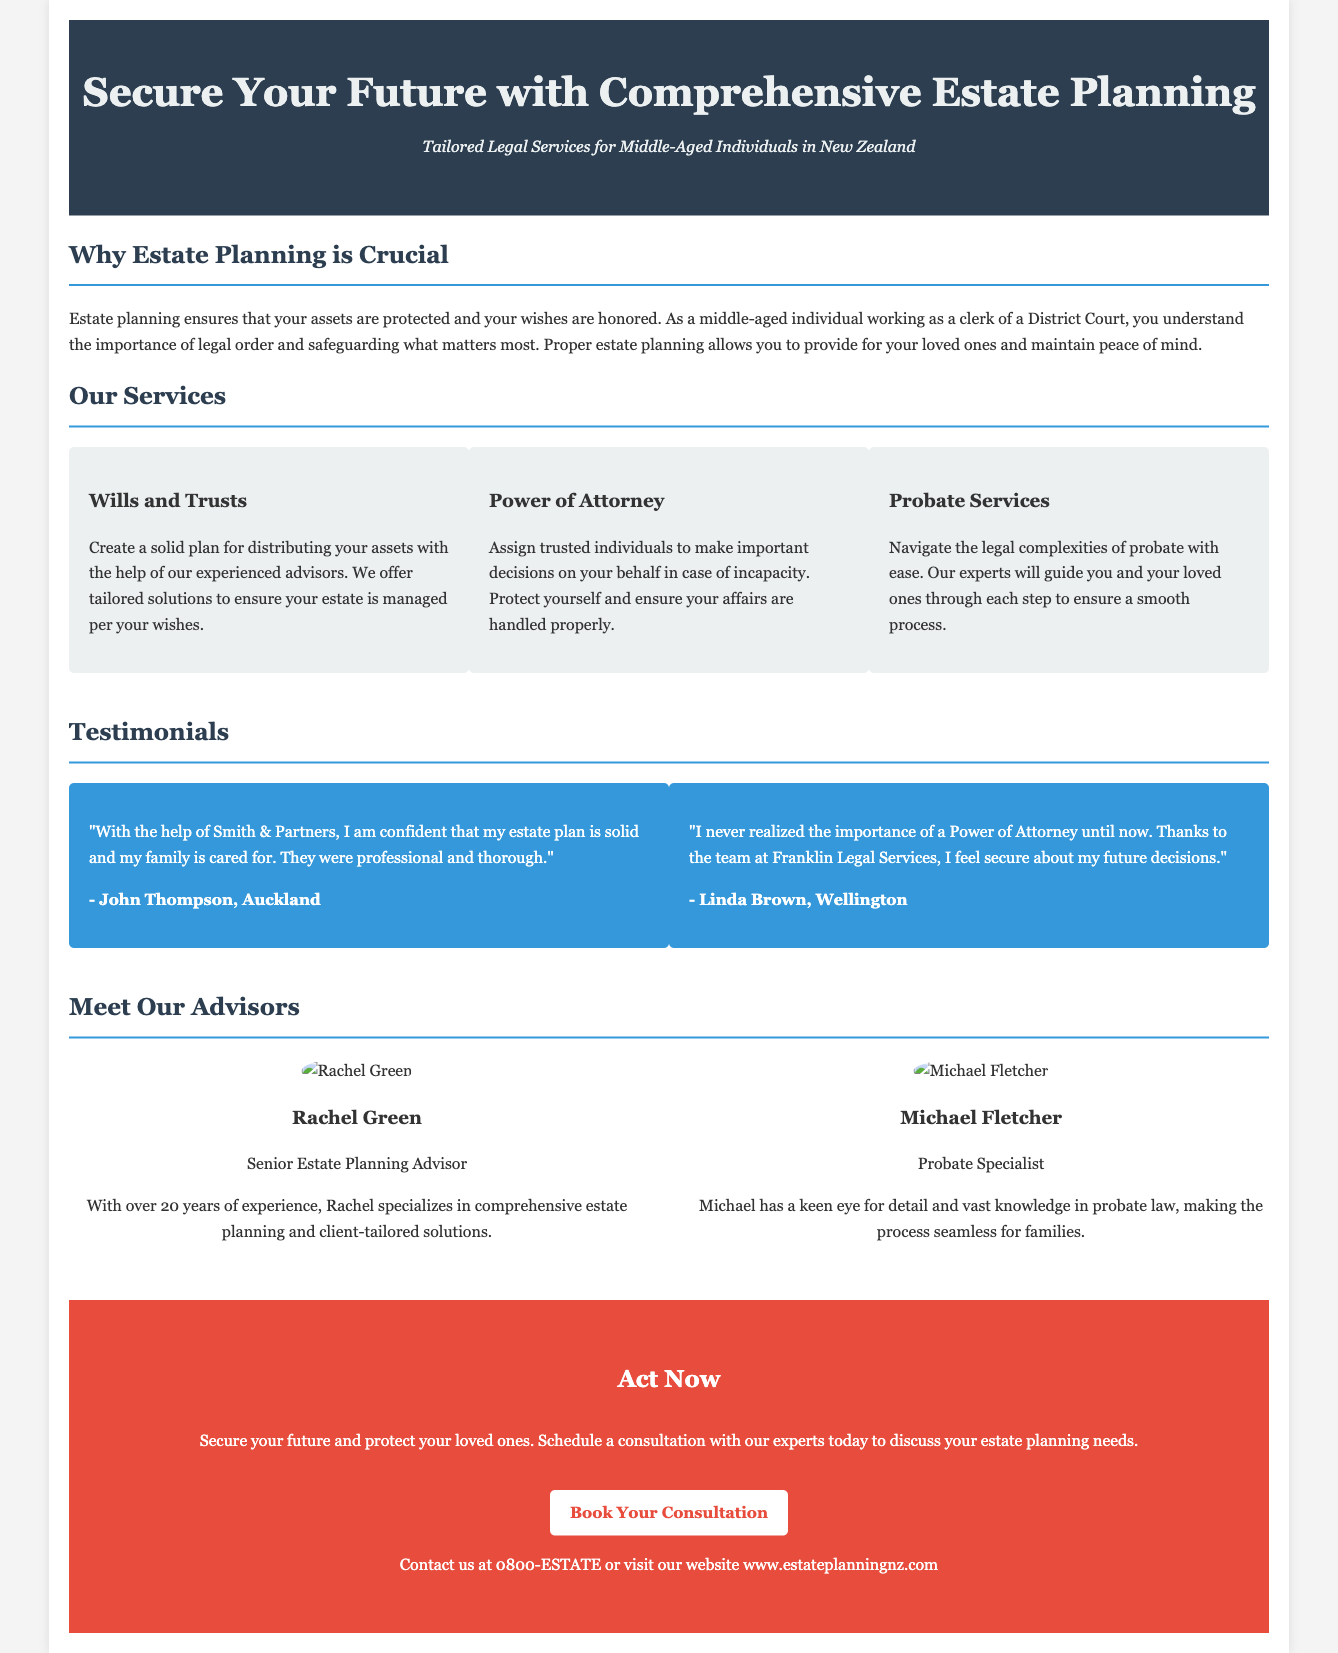what is the title of the advertisement? The title of the advertisement is prominently displayed at the top of the document for easy visibility.
Answer: Secure Your Future with Comprehensive Estate Planning who is the senior estate planning advisor mentioned? The document highlights the expertise of the advisors involved, specifically mentioning Rachel Green's title.
Answer: Rachel Green what services are offered for power of attorney? The advertisement clearly lays out different legal services available, including details on power of attorney.
Answer: Assign trusted individuals to make important decisions how many testimonials are included in the advertisement? The document provides a section for customer feedback, specifying the count of quotes presented.
Answer: Two where is the contact phone number for consultations? The contact information in the call-to-action section provides multiple ways to reach out for services.
Answer: 0800-ESTATE what city is John Thompson from? The advertisement includes specific testimonials, which reveal the location of each individual providing feedback.
Answer: Auckland who specializes in probate law? The document indicates the role and specialty of one of the legal advisors, specifically mentioning their expertise.
Answer: Michael Fletcher what is the primary purpose of estate planning according to the document? The introduction section establishes the main objective of the services provided in the advertisement.
Answer: Protecting your assets and honoring your wishes what is the background color of the cta section? The design elements of the advertisement describe different sections, including the distinct color used for emphasis.
Answer: #e74c3c 